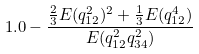Convert formula to latex. <formula><loc_0><loc_0><loc_500><loc_500>1 . 0 - \frac { \frac { 2 } { 3 } E ( q _ { 1 2 } ^ { 2 } ) ^ { 2 } + \frac { 1 } { 3 } E ( q _ { 1 2 } ^ { 4 } ) } { E ( q _ { 1 2 } ^ { 2 } q _ { 3 4 } ^ { 2 } ) }</formula> 